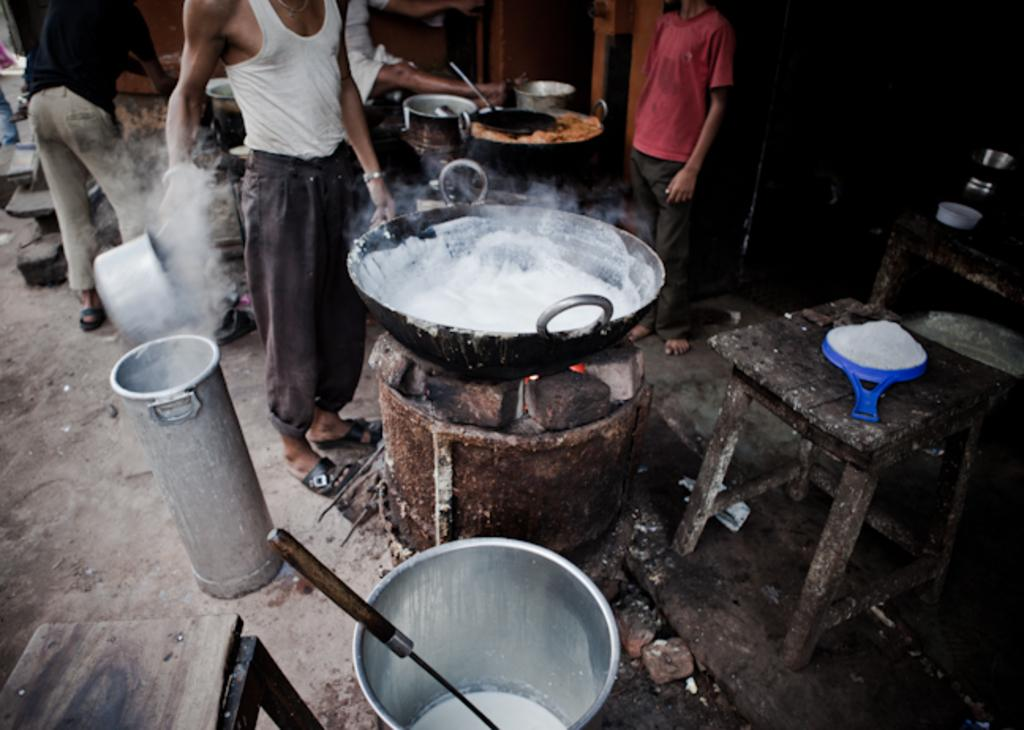What can be observed about the people in the image? There are people standing in the image. What are the people wearing? The people are wearing clothes. What type of containers can be seen in the image? There are food containers in the image. What piece of furniture is present in the image? There is a stool in the image. What type of food item is visible in the image? There is a food item in the image. Can you describe any other items present in the image? There are other unspecified items in the image. How does the stone burst in the image? There is no stone or bursting action present in the image. 